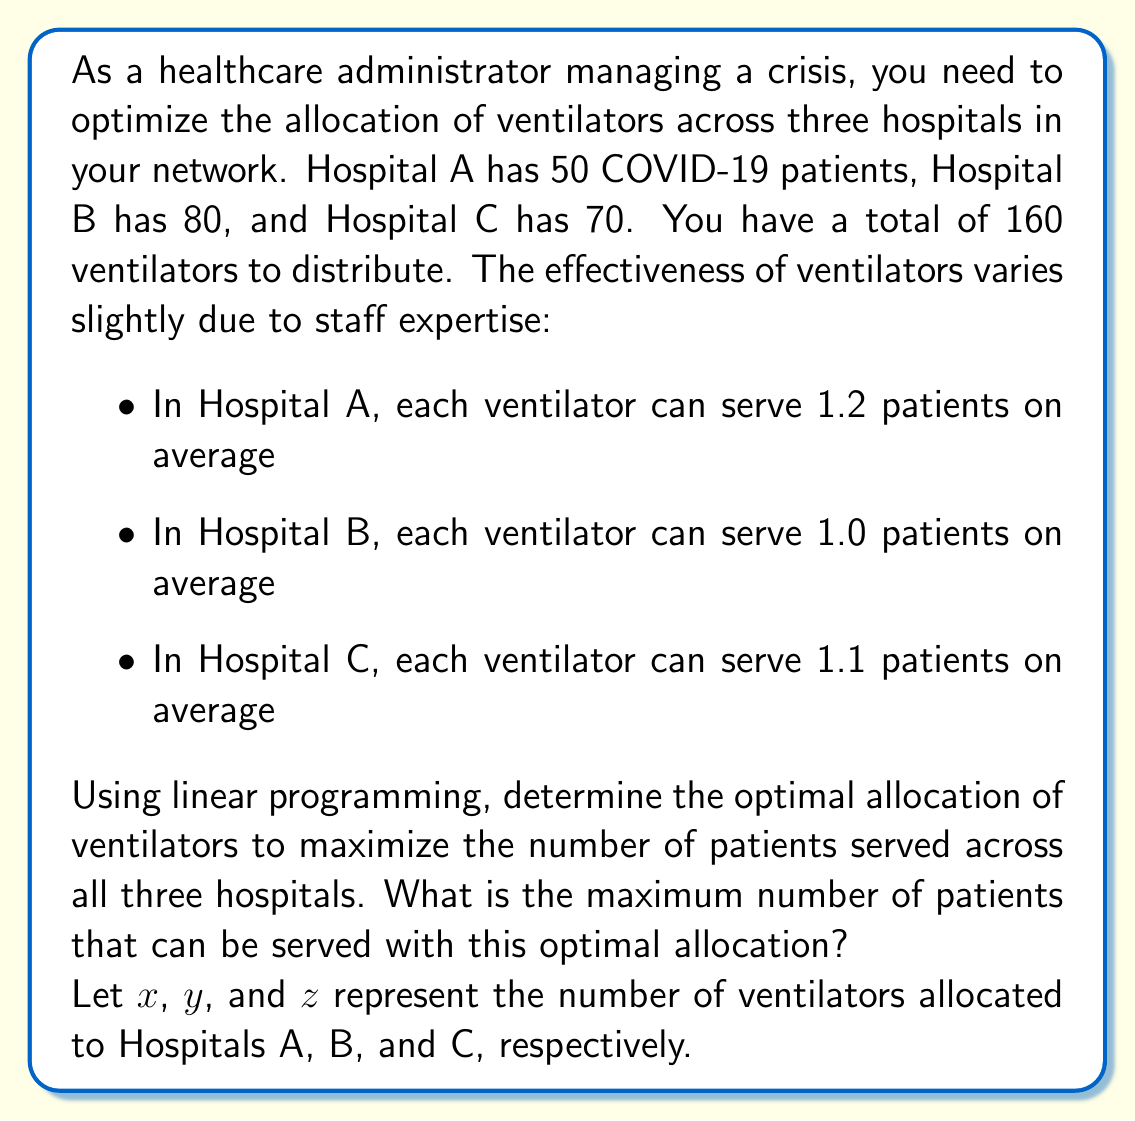Solve this math problem. To solve this problem using linear programming, we need to set up the objective function and constraints:

Objective function (maximize): $1.2x + 1.0y + 1.1z$

Constraints:
1. Total ventilators: $x + y + z \leq 160$
2. Hospital A capacity: $1.2x \leq 50$
3. Hospital B capacity: $1.0y \leq 80$
4. Hospital C capacity: $1.1z \leq 70$
5. Non-negativity: $x, y, z \geq 0$

Steps to solve:

1. Simplify the constraints:
   $x + y + z \leq 160$
   $x \leq 41.67$
   $y \leq 80$
   $z \leq 63.64$

2. The optimal solution will occur at the intersection of these constraints. We can allocate the maximum to each hospital without exceeding its capacity:

   Hospital A: $x = 41.67$ (rounded down to 41)
   Hospital B: $y = 80$
   Hospital C: $z = 63.64$ (rounded down to 63)

3. Check if this allocation satisfies the total ventilator constraint:
   $41 + 80 + 63 = 184$ > 160

   This exceeds our total, so we need to adjust.

4. We should prioritize hospitals with higher effectiveness. Keep Hospital A at 41 and Hospital C at 63, then allocate the remaining to Hospital B:

   $160 - 41 - 63 = 56$ ventilators for Hospital B

5. Calculate the number of patients served:
   Hospital A: $1.2 \times 41 = 49.2$
   Hospital B: $1.0 \times 56 = 56$
   Hospital C: $1.1 \times 63 = 69.3$

6. Total patients served: $49.2 + 56 + 69.3 = 174.5$
Answer: The optimal allocation is 41 ventilators to Hospital A, 56 to Hospital B, and 63 to Hospital C. This allocation can serve a maximum of 174.5 patients. 